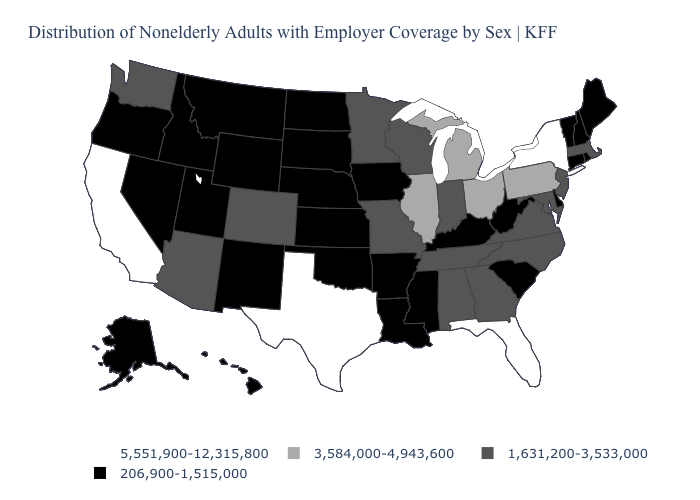What is the value of Minnesota?
Give a very brief answer. 1,631,200-3,533,000. What is the value of Maine?
Write a very short answer. 206,900-1,515,000. Name the states that have a value in the range 206,900-1,515,000?
Answer briefly. Alaska, Arkansas, Connecticut, Delaware, Hawaii, Idaho, Iowa, Kansas, Kentucky, Louisiana, Maine, Mississippi, Montana, Nebraska, Nevada, New Hampshire, New Mexico, North Dakota, Oklahoma, Oregon, Rhode Island, South Carolina, South Dakota, Utah, Vermont, West Virginia, Wyoming. Does Delaware have the same value as Tennessee?
Give a very brief answer. No. What is the value of South Carolina?
Short answer required. 206,900-1,515,000. Name the states that have a value in the range 206,900-1,515,000?
Give a very brief answer. Alaska, Arkansas, Connecticut, Delaware, Hawaii, Idaho, Iowa, Kansas, Kentucky, Louisiana, Maine, Mississippi, Montana, Nebraska, Nevada, New Hampshire, New Mexico, North Dakota, Oklahoma, Oregon, Rhode Island, South Carolina, South Dakota, Utah, Vermont, West Virginia, Wyoming. What is the highest value in the South ?
Concise answer only. 5,551,900-12,315,800. Name the states that have a value in the range 1,631,200-3,533,000?
Answer briefly. Alabama, Arizona, Colorado, Georgia, Indiana, Maryland, Massachusetts, Minnesota, Missouri, New Jersey, North Carolina, Tennessee, Virginia, Washington, Wisconsin. Which states hav the highest value in the South?
Be succinct. Florida, Texas. Name the states that have a value in the range 5,551,900-12,315,800?
Give a very brief answer. California, Florida, New York, Texas. What is the lowest value in the USA?
Concise answer only. 206,900-1,515,000. What is the highest value in states that border Kentucky?
Answer briefly. 3,584,000-4,943,600. Name the states that have a value in the range 5,551,900-12,315,800?
Keep it brief. California, Florida, New York, Texas. What is the lowest value in the West?
Give a very brief answer. 206,900-1,515,000. Name the states that have a value in the range 206,900-1,515,000?
Answer briefly. Alaska, Arkansas, Connecticut, Delaware, Hawaii, Idaho, Iowa, Kansas, Kentucky, Louisiana, Maine, Mississippi, Montana, Nebraska, Nevada, New Hampshire, New Mexico, North Dakota, Oklahoma, Oregon, Rhode Island, South Carolina, South Dakota, Utah, Vermont, West Virginia, Wyoming. 